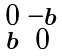<formula> <loc_0><loc_0><loc_500><loc_500>\begin{smallmatrix} 0 & - b \\ b & 0 \end{smallmatrix}</formula> 